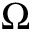<formula> <loc_0><loc_0><loc_500><loc_500>\Omega</formula> 